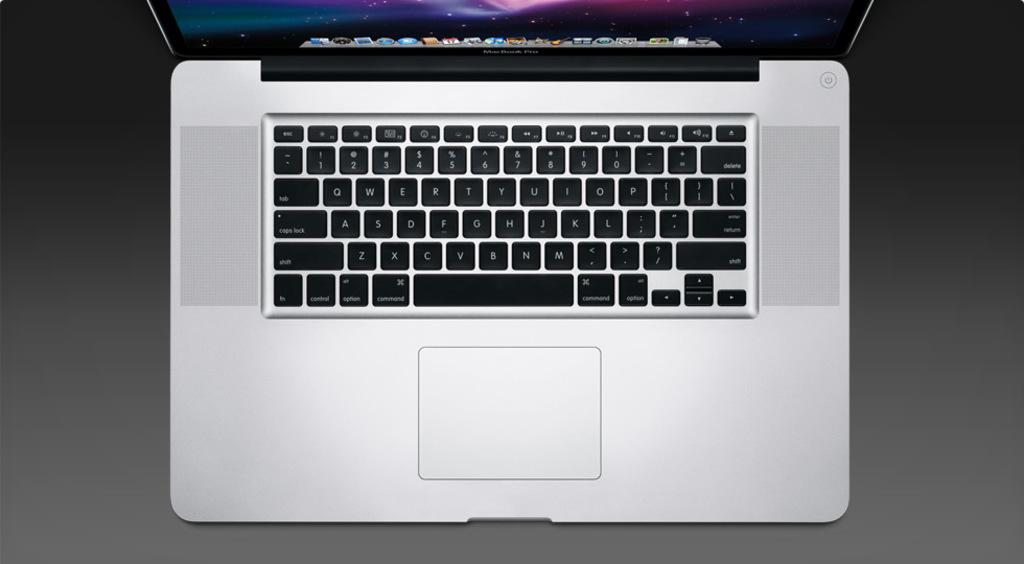<image>
Share a concise interpretation of the image provided. An open laptop computer has Command keys to the left and right of the space bar. 